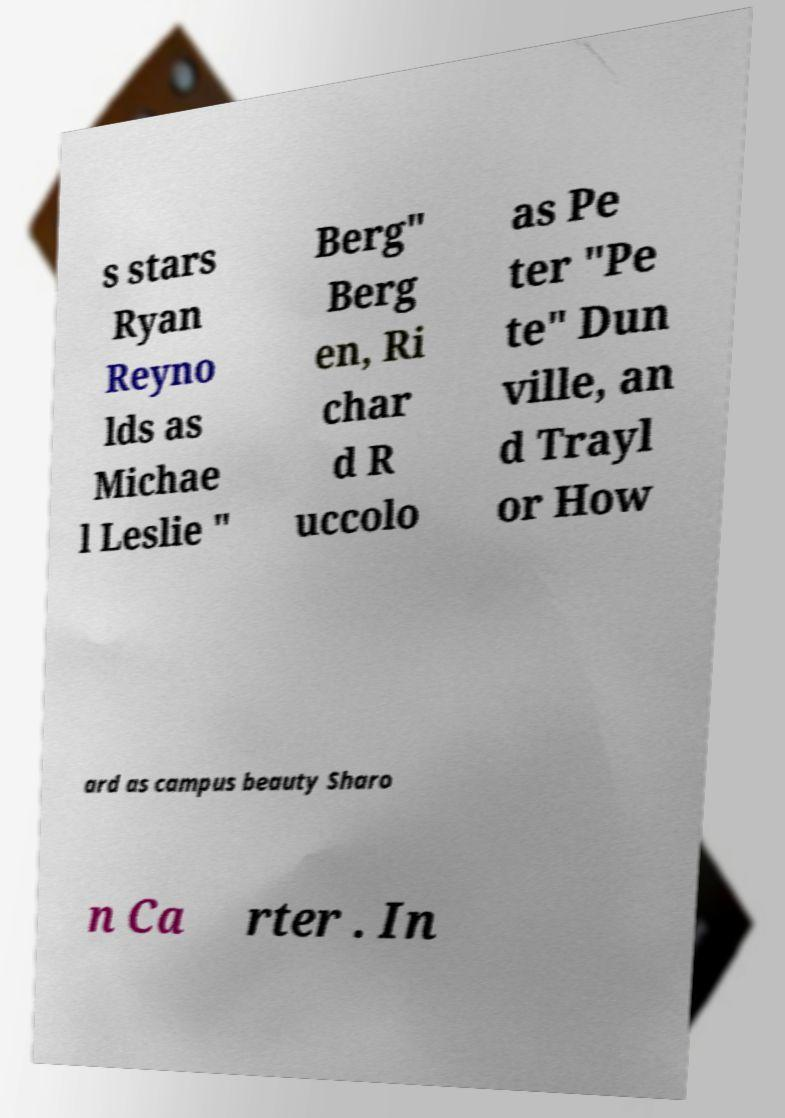For documentation purposes, I need the text within this image transcribed. Could you provide that? s stars Ryan Reyno lds as Michae l Leslie " Berg" Berg en, Ri char d R uccolo as Pe ter "Pe te" Dun ville, an d Trayl or How ard as campus beauty Sharo n Ca rter . In 